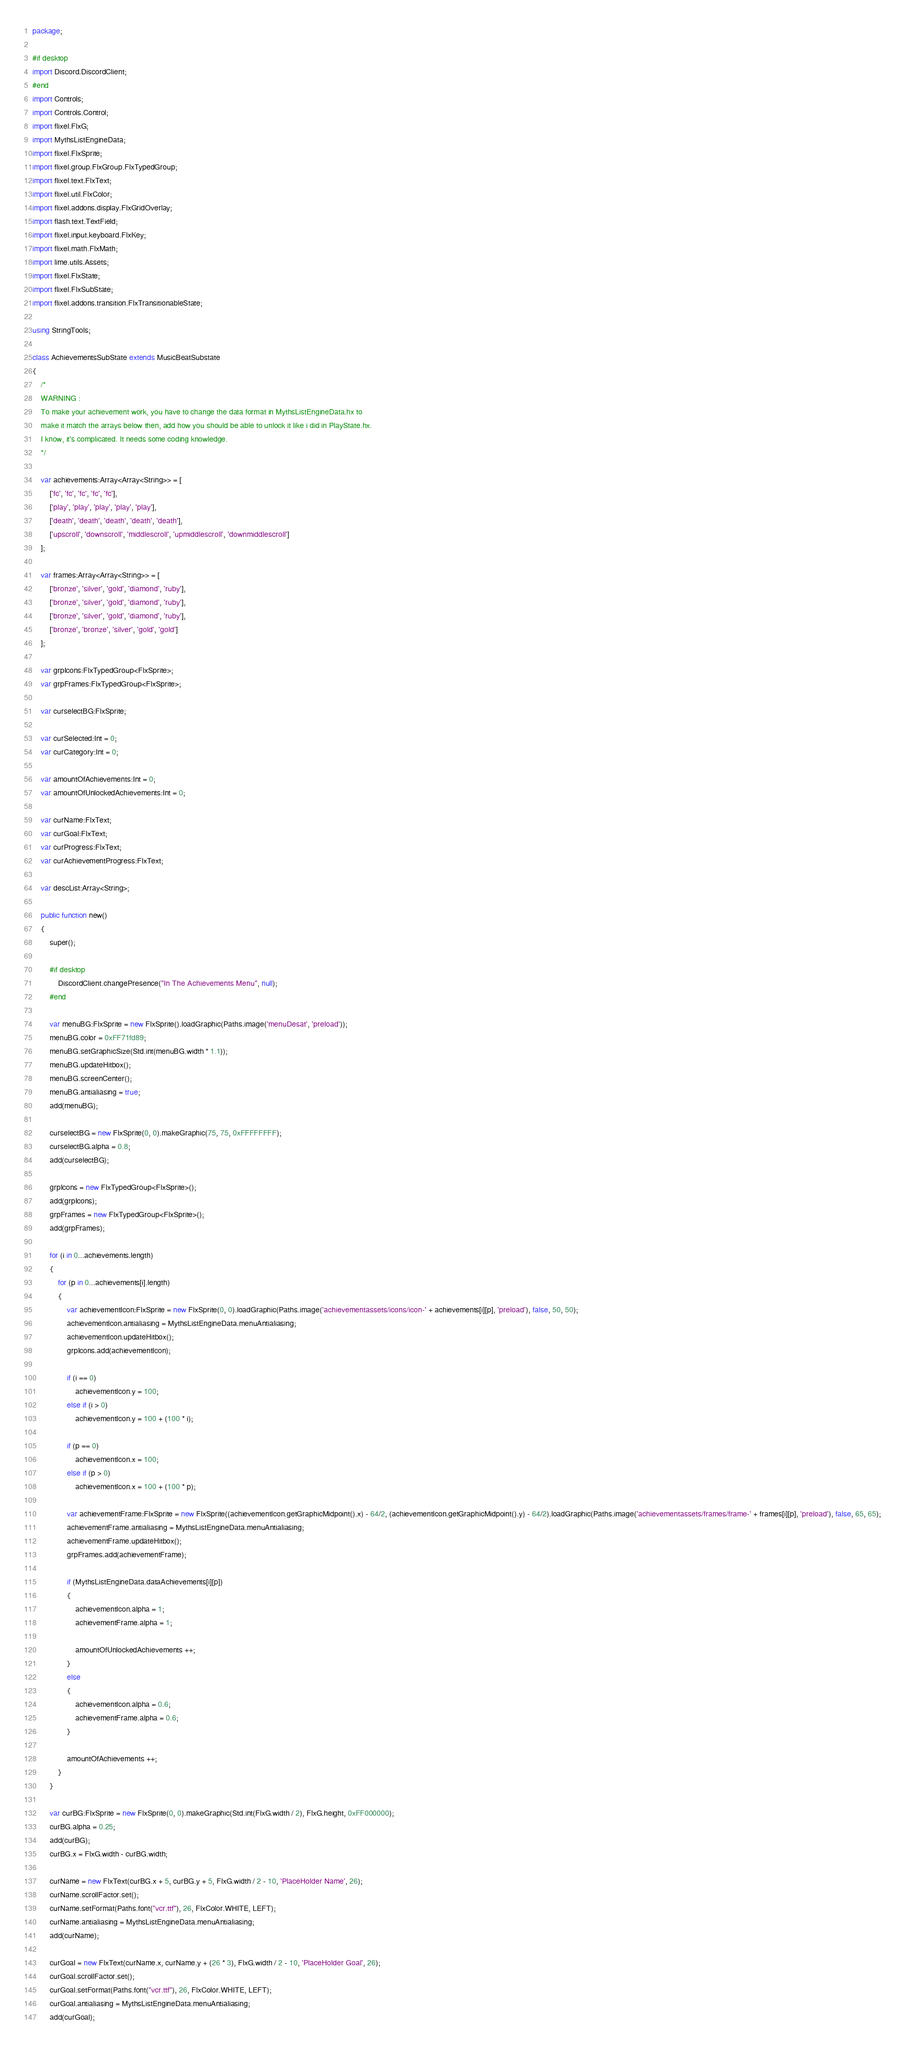<code> <loc_0><loc_0><loc_500><loc_500><_Haxe_>package;

#if desktop
import Discord.DiscordClient;
#end
import Controls;
import Controls.Control;
import flixel.FlxG;
import MythsListEngineData;
import flixel.FlxSprite;
import flixel.group.FlxGroup.FlxTypedGroup;
import flixel.text.FlxText;
import flixel.util.FlxColor;
import flixel.addons.display.FlxGridOverlay;
import flash.text.TextField;
import flixel.input.keyboard.FlxKey;
import flixel.math.FlxMath;
import lime.utils.Assets;
import flixel.FlxState;
import flixel.FlxSubState;
import flixel.addons.transition.FlxTransitionableState;

using StringTools;

class AchievementsSubState extends MusicBeatSubstate
{
	/*
	WARNING :
	To make your achievement work, you have to change the data format in MythsListEngineData.hx to
	make it match the arrays below then, add how you should be able to unlock it like i did in PlayState.hx.
	I know, it's complicated. It needs some coding knowledge.
	*/

	var achievements:Array<Array<String>> = [
		['fc', 'fc', 'fc', 'fc', 'fc'],
		['play', 'play', 'play', 'play', 'play'],
		['death', 'death', 'death', 'death', 'death'],
		['upscroll', 'downscroll', 'middlescroll', 'upmiddlescroll', 'downmiddlescroll']
	];

	var frames:Array<Array<String>> = [
		['bronze', 'silver', 'gold', 'diamond', 'ruby'],
		['bronze', 'silver', 'gold', 'diamond', 'ruby'],
		['bronze', 'silver', 'gold', 'diamond', 'ruby'],
		['bronze', 'bronze', 'silver', 'gold', 'gold']
	];

	var grpIcons:FlxTypedGroup<FlxSprite>;
	var grpFrames:FlxTypedGroup<FlxSprite>;

	var curselectBG:FlxSprite;

	var curSelected:Int = 0;
	var curCategory:Int = 0;

	var amountOfAchievements:Int = 0;
	var amountOfUnlockedAchievements:Int = 0;

	var curName:FlxText;
	var curGoal:FlxText;
	var curProgress:FlxText;
	var curAchievementProgress:FlxText;

	var descList:Array<String>;

	public function new()
	{
		super();

		#if desktop
			DiscordClient.changePresence("In The Achievements Menu", null);
		#end

		var menuBG:FlxSprite = new FlxSprite().loadGraphic(Paths.image('menuDesat', 'preload'));
		menuBG.color = 0xFF71fd89;
		menuBG.setGraphicSize(Std.int(menuBG.width * 1.1));
		menuBG.updateHitbox();
		menuBG.screenCenter();
		menuBG.antialiasing = true;
		add(menuBG);

		curselectBG = new FlxSprite(0, 0).makeGraphic(75, 75, 0xFFFFFFFF);
		curselectBG.alpha = 0.8;
		add(curselectBG);

		grpIcons = new FlxTypedGroup<FlxSprite>();
		add(grpIcons);
		grpFrames = new FlxTypedGroup<FlxSprite>();
		add(grpFrames);

		for (i in 0...achievements.length)
		{
			for (p in 0...achievements[i].length)
			{
				var achievementIcon:FlxSprite = new FlxSprite(0, 0).loadGraphic(Paths.image('achievementassets/icons/icon-' + achievements[i][p], 'preload'), false, 50, 50);
				achievementIcon.antialiasing = MythsListEngineData.menuAntialiasing;
				achievementIcon.updateHitbox();
				grpIcons.add(achievementIcon);

				if (i == 0)
					achievementIcon.y = 100;
				else if (i > 0)
					achievementIcon.y = 100 + (100 * i);
		
				if (p == 0)
					achievementIcon.x = 100;
				else if (p > 0)
					achievementIcon.x = 100 + (100 * p);
		
				var achievementFrame:FlxSprite = new FlxSprite((achievementIcon.getGraphicMidpoint().x) - 64/2, (achievementIcon.getGraphicMidpoint().y) - 64/2).loadGraphic(Paths.image('achievementassets/frames/frame-' + frames[i][p], 'preload'), false, 65, 65);
				achievementFrame.antialiasing = MythsListEngineData.menuAntialiasing;
				achievementFrame.updateHitbox();
				grpFrames.add(achievementFrame);
	
				if (MythsListEngineData.dataAchievements[i][p])
				{
					achievementIcon.alpha = 1;
					achievementFrame.alpha = 1;

					amountOfUnlockedAchievements ++;
				}
				else
				{
					achievementIcon.alpha = 0.6;
					achievementFrame.alpha = 0.6;
				}

				amountOfAchievements ++;
			}
		}

		var curBG:FlxSprite = new FlxSprite(0, 0).makeGraphic(Std.int(FlxG.width / 2), FlxG.height, 0xFF000000);
		curBG.alpha = 0.25;
		add(curBG);
		curBG.x = FlxG.width - curBG.width;

		curName = new FlxText(curBG.x + 5, curBG.y + 5, FlxG.width / 2 - 10, 'PlaceHolder Name', 26);
		curName.scrollFactor.set();
		curName.setFormat(Paths.font("vcr.ttf"), 26, FlxColor.WHITE, LEFT);
		curName.antialiasing = MythsListEngineData.menuAntialiasing;
		add(curName);

		curGoal = new FlxText(curName.x, curName.y + (26 * 3), FlxG.width / 2 - 10, 'PlaceHolder Goal', 26);
		curGoal.scrollFactor.set();
		curGoal.setFormat(Paths.font("vcr.ttf"), 26, FlxColor.WHITE, LEFT);
		curGoal.antialiasing = MythsListEngineData.menuAntialiasing;
		add(curGoal);
</code> 